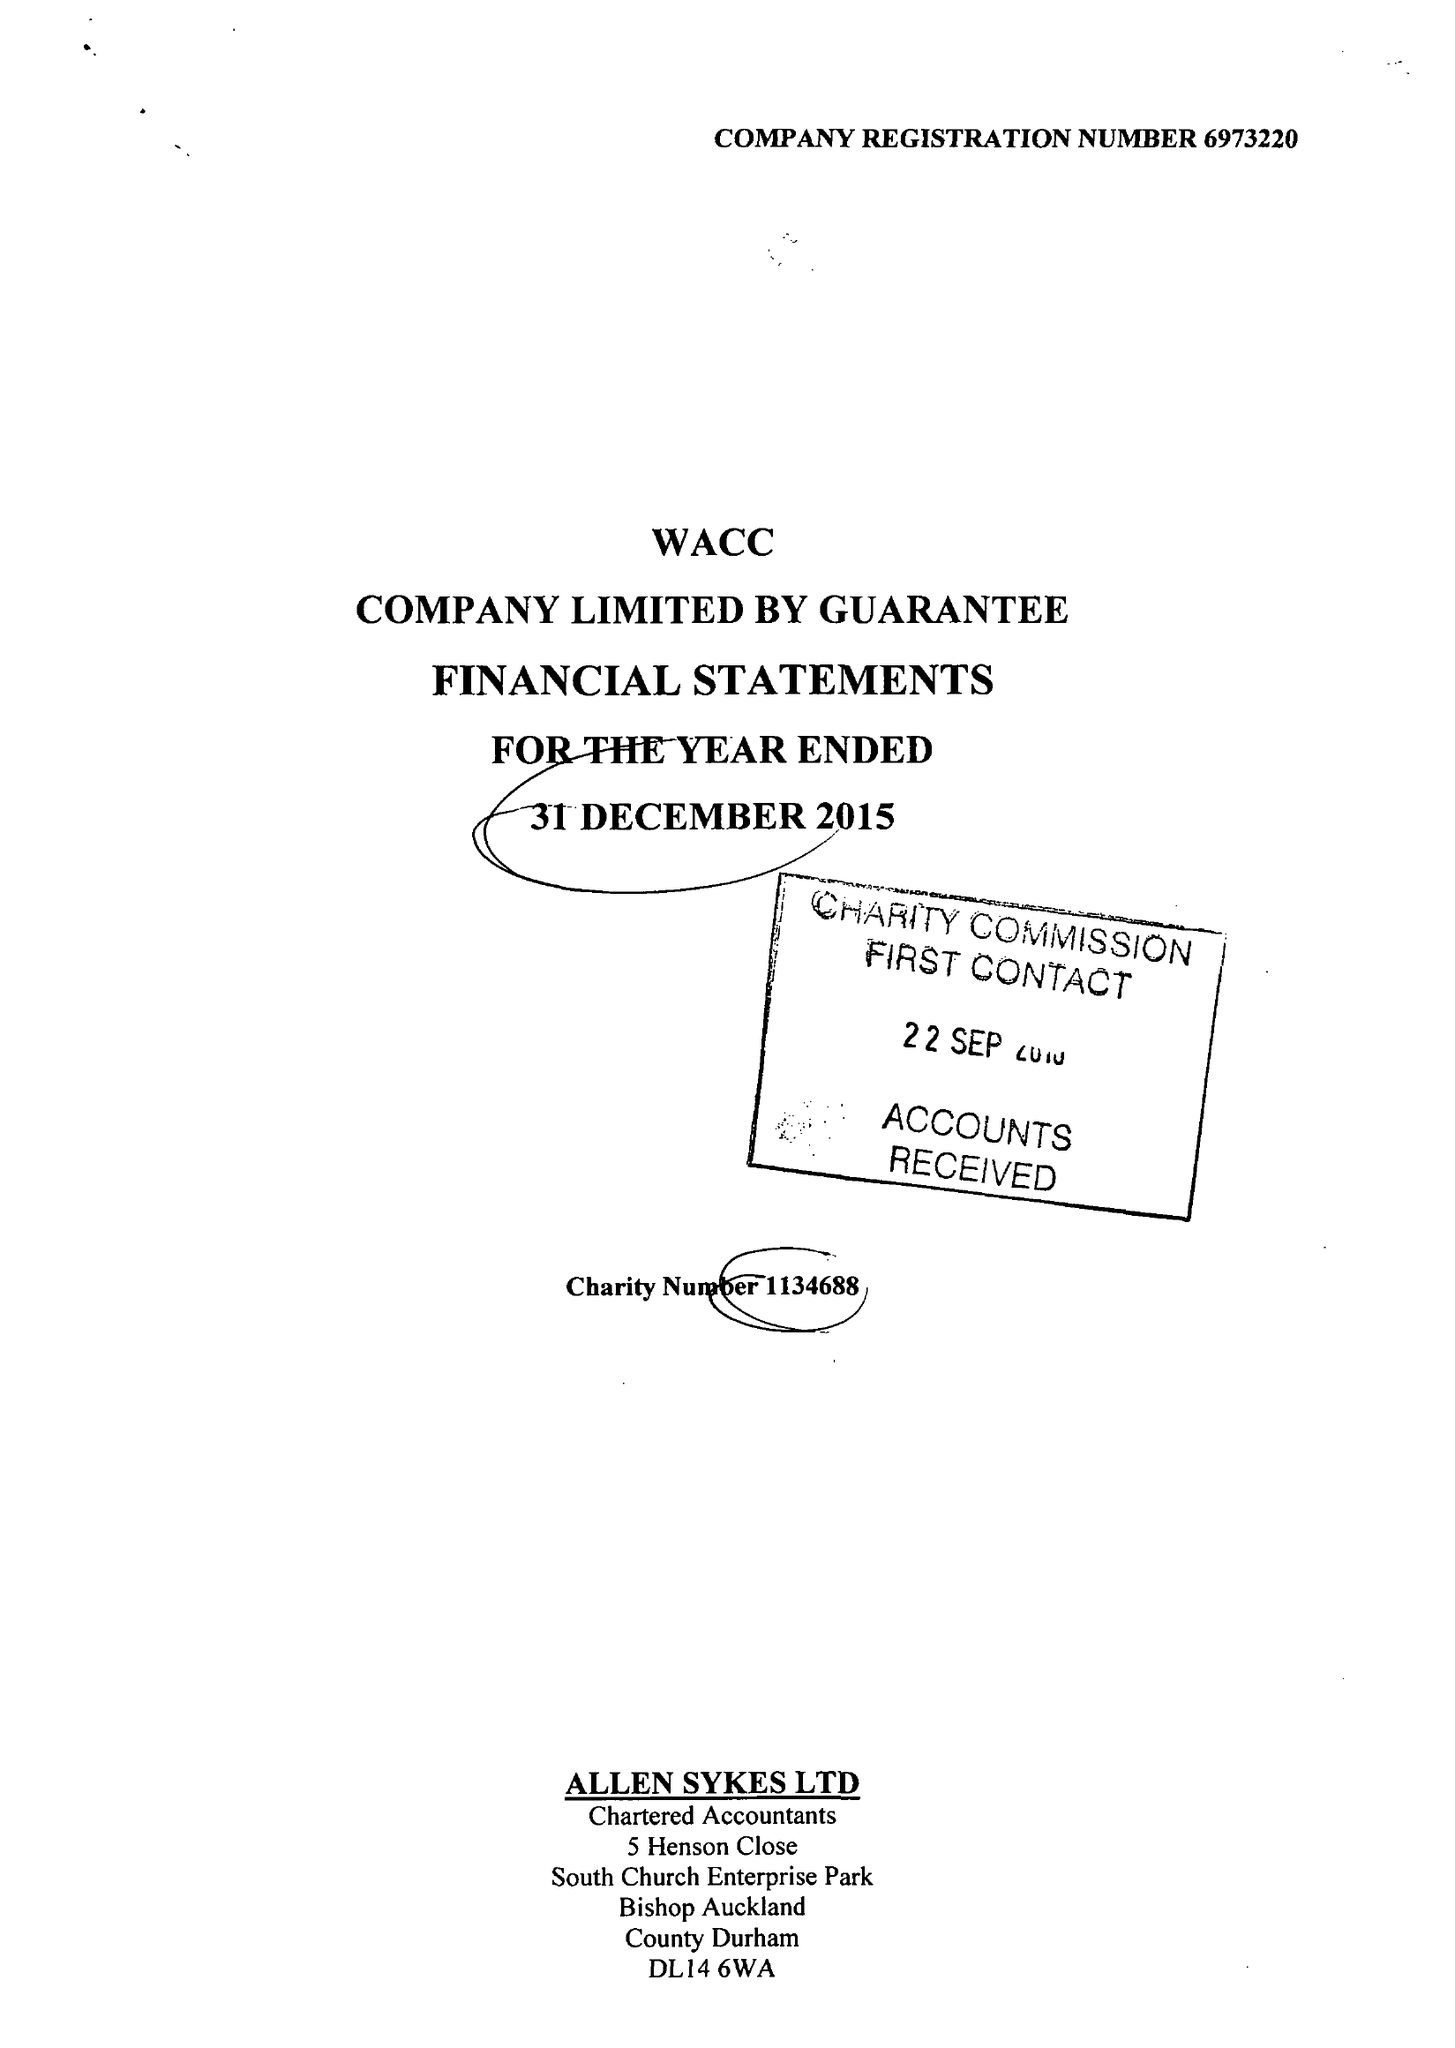What is the value for the charity_name?
Answer the question using a single word or phrase. West Auckland Community Church 